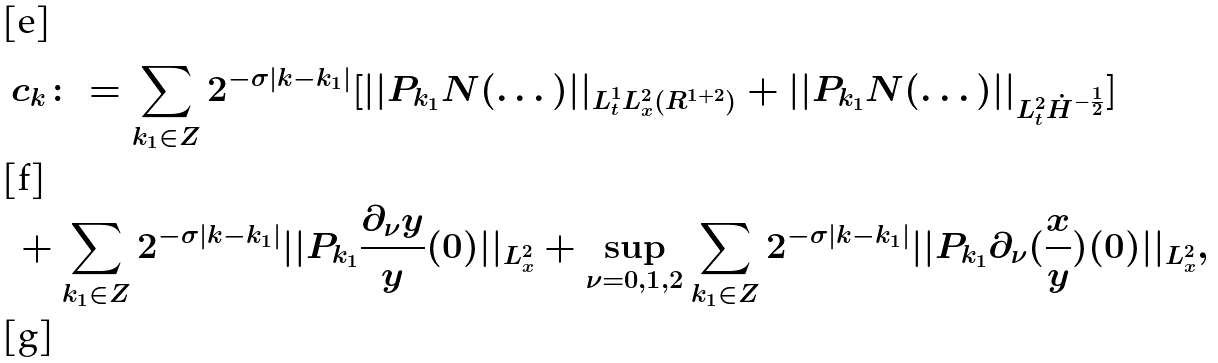Convert formula to latex. <formula><loc_0><loc_0><loc_500><loc_500>& c _ { k } \colon = \sum _ { k _ { 1 } \in { Z } } 2 ^ { - \sigma | k - k _ { 1 } | } [ | | P _ { k _ { 1 } } N ( \dots ) | | _ { L _ { t } ^ { 1 } L _ { x } ^ { 2 } ( { R } ^ { 1 + 2 } ) } + | | P _ { k _ { 1 } } N ( \dots ) | | _ { L _ { t } ^ { 2 } \dot { H } ^ { - \frac { 1 } { 2 } } } ] \\ & + \sum _ { k _ { 1 } \in { Z } } 2 ^ { - \sigma | k - k _ { 1 } | } | | P _ { k _ { 1 } } \frac { \partial _ { \nu } { y } } { y } ( 0 ) | | _ { L _ { x } ^ { 2 } } + \sup _ { \nu = 0 , 1 , 2 } \sum _ { k _ { 1 } \in { Z } } 2 ^ { - \sigma | k - k _ { 1 } | } | | P _ { k _ { 1 } } \partial _ { \nu } ( \frac { x } { y } ) ( 0 ) | | _ { L _ { x } ^ { 2 } } , \\</formula> 